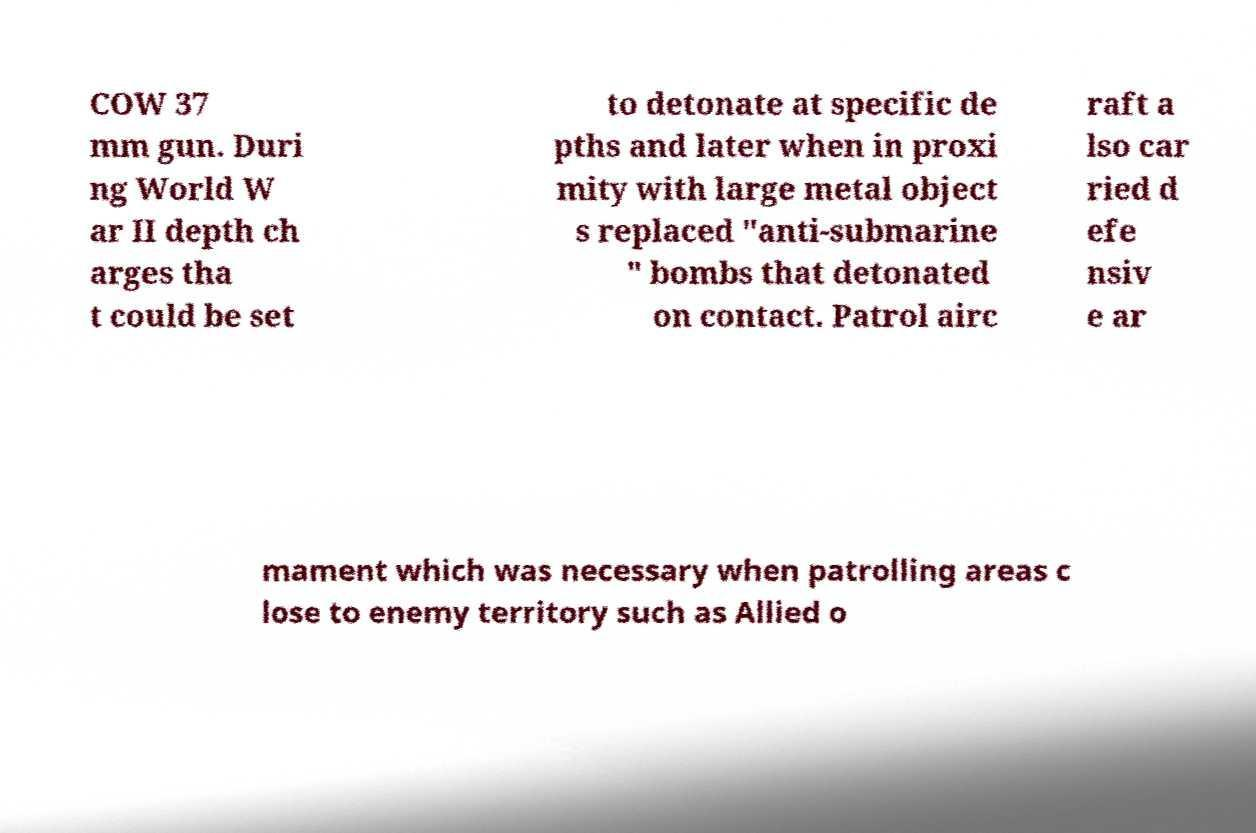Could you assist in decoding the text presented in this image and type it out clearly? COW 37 mm gun. Duri ng World W ar II depth ch arges tha t could be set to detonate at specific de pths and later when in proxi mity with large metal object s replaced "anti-submarine " bombs that detonated on contact. Patrol airc raft a lso car ried d efe nsiv e ar mament which was necessary when patrolling areas c lose to enemy territory such as Allied o 